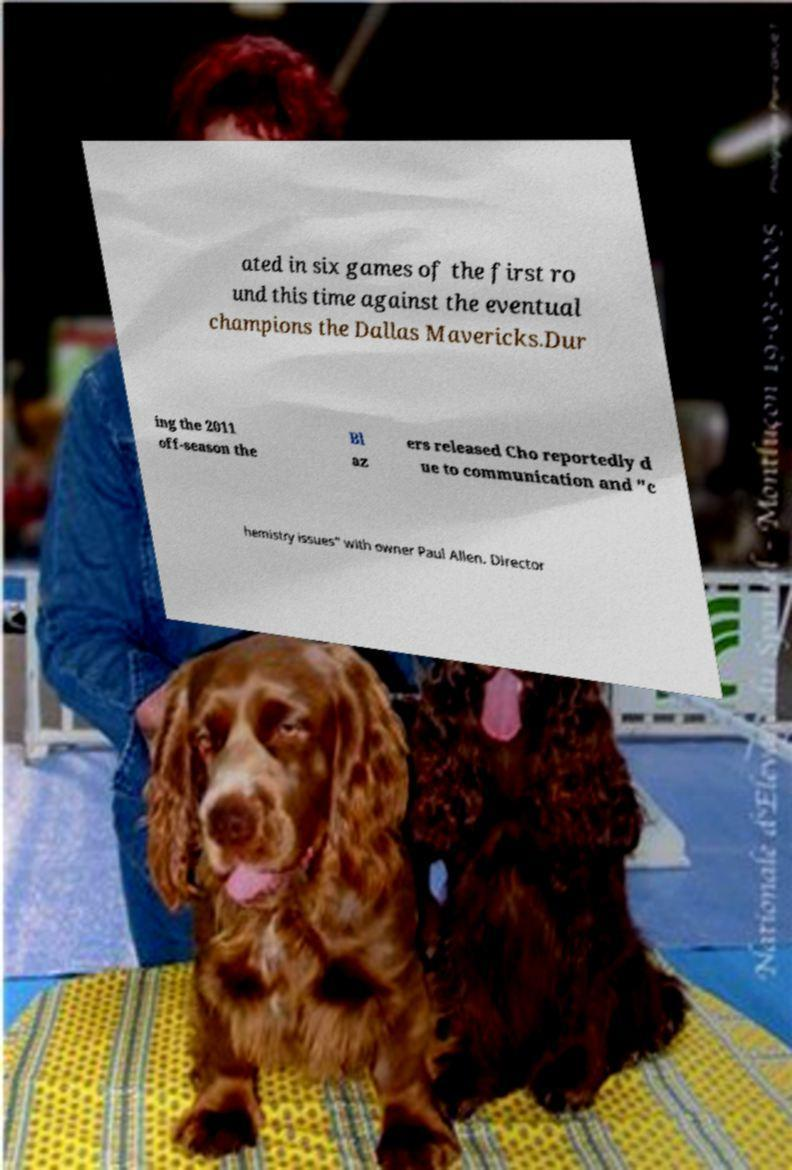I need the written content from this picture converted into text. Can you do that? ated in six games of the first ro und this time against the eventual champions the Dallas Mavericks.Dur ing the 2011 off-season the Bl az ers released Cho reportedly d ue to communication and "c hemistry issues" with owner Paul Allen. Director 